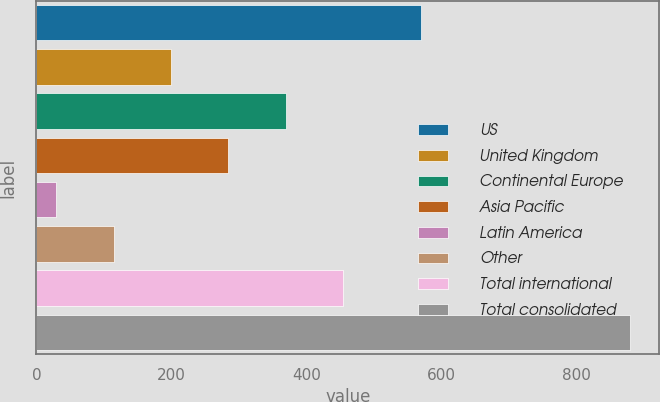<chart> <loc_0><loc_0><loc_500><loc_500><bar_chart><fcel>US<fcel>United Kingdom<fcel>Continental Europe<fcel>Asia Pacific<fcel>Latin America<fcel>Other<fcel>Total international<fcel>Total consolidated<nl><fcel>569.9<fcel>199.1<fcel>368.8<fcel>283.95<fcel>29.4<fcel>114.25<fcel>453.65<fcel>877.9<nl></chart> 